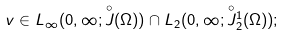<formula> <loc_0><loc_0><loc_500><loc_500>v \in L _ { \infty } ( 0 , \infty ; \overset { \circ } { J } ( \Omega ) ) \cap L _ { 2 } ( 0 , \infty ; \overset { \circ } { J } { ^ { 1 } _ { 2 } } ( \Omega ) ) ;</formula> 